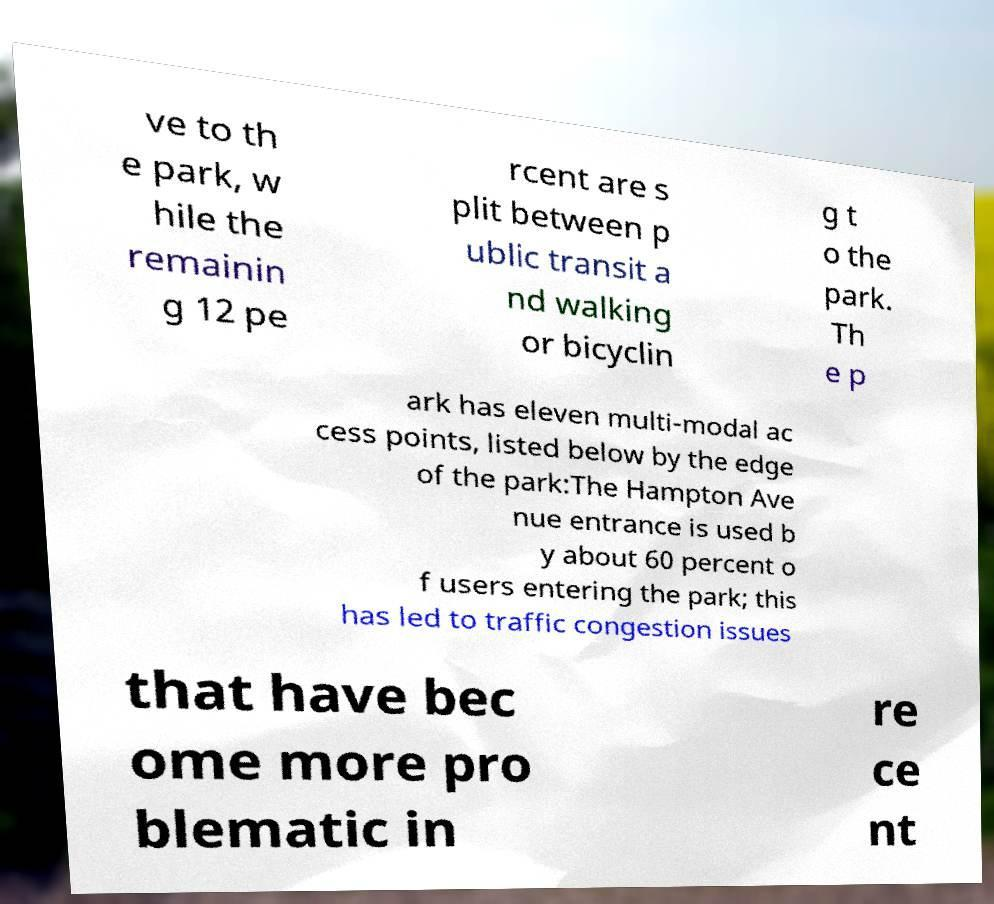I need the written content from this picture converted into text. Can you do that? ve to th e park, w hile the remainin g 12 pe rcent are s plit between p ublic transit a nd walking or bicyclin g t o the park. Th e p ark has eleven multi-modal ac cess points, listed below by the edge of the park:The Hampton Ave nue entrance is used b y about 60 percent o f users entering the park; this has led to traffic congestion issues that have bec ome more pro blematic in re ce nt 